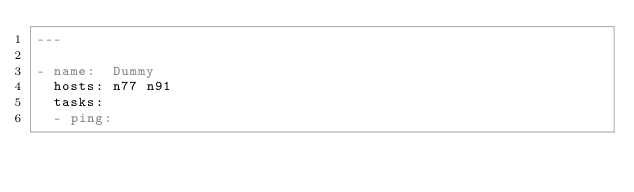Convert code to text. <code><loc_0><loc_0><loc_500><loc_500><_YAML_>---

- name:  Dummy
  hosts: n77 n91
  tasks:
  - ping:
</code> 